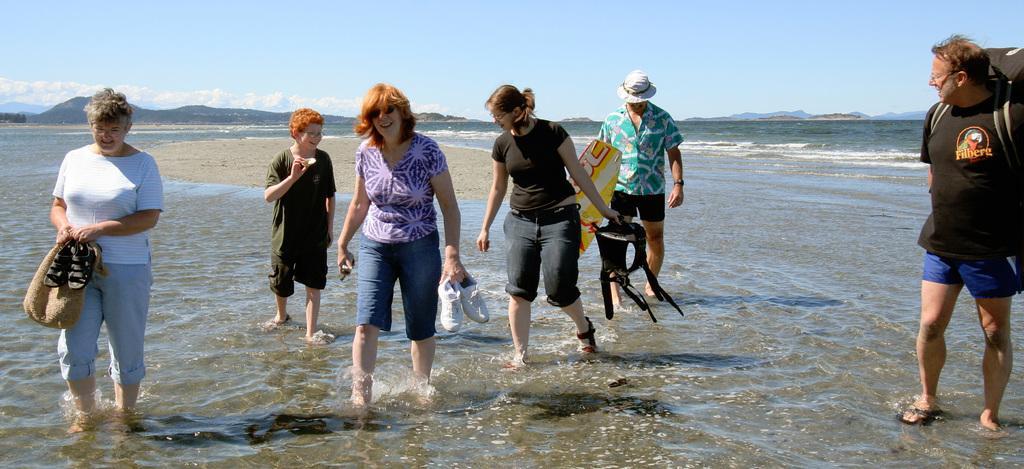Can you describe this image briefly? In this image I can see people are standing in the water. These people are holding some objects. In the background I can see mountains and the sky. 